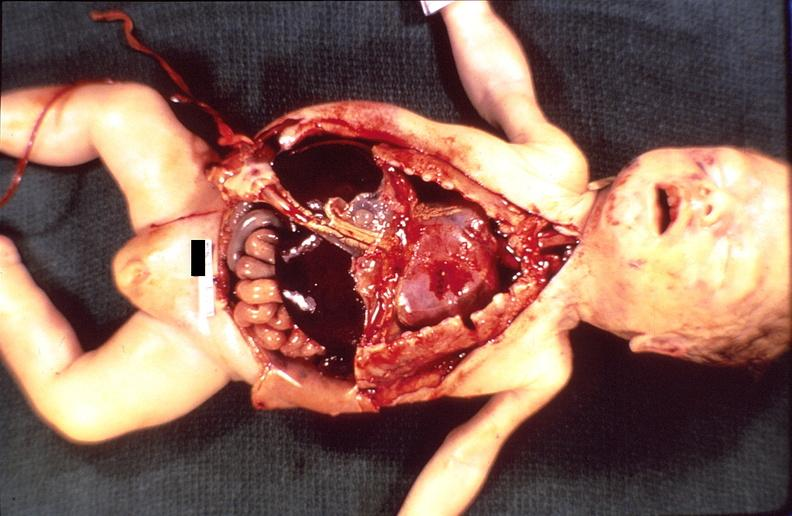does sacrococcygeal teratoma show hemolytic disease of newborn?
Answer the question using a single word or phrase. No 